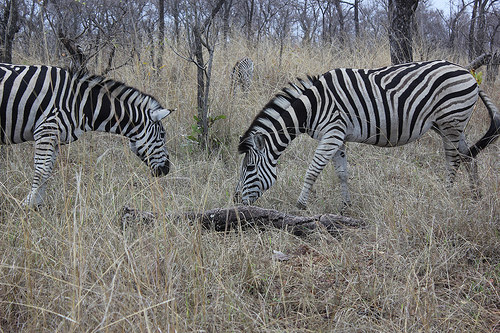Do you see zebras in the grass? Yes, there are two zebras grazing peacefully among the dry grass, showcasing their distinctive black and white stripes which provide camouflage in the wild. 